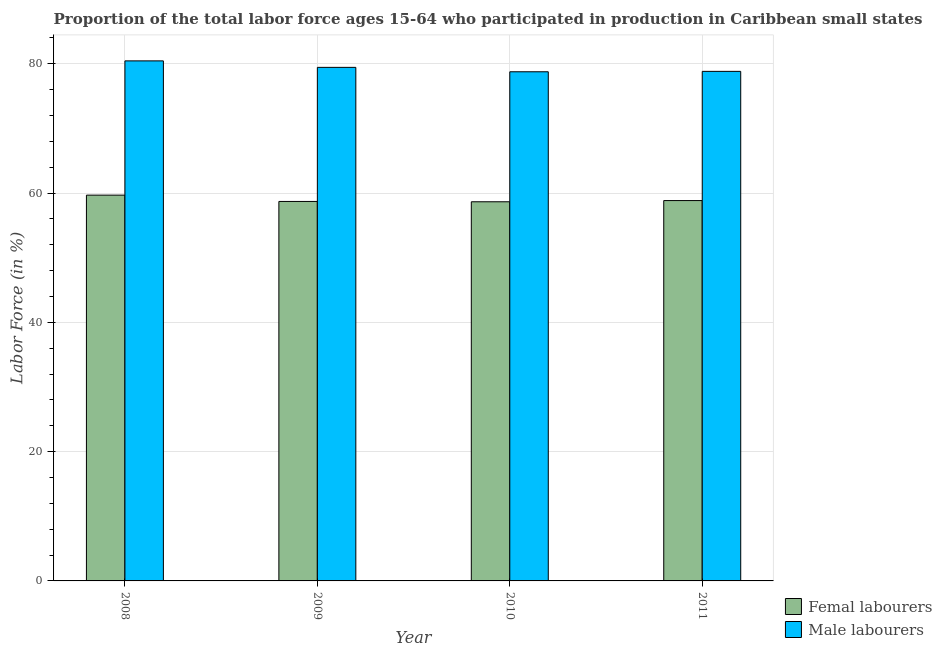How many different coloured bars are there?
Your answer should be very brief. 2. How many groups of bars are there?
Provide a succinct answer. 4. Are the number of bars on each tick of the X-axis equal?
Keep it short and to the point. Yes. How many bars are there on the 3rd tick from the right?
Give a very brief answer. 2. What is the label of the 2nd group of bars from the left?
Keep it short and to the point. 2009. What is the percentage of female labor force in 2008?
Your answer should be very brief. 59.68. Across all years, what is the maximum percentage of female labor force?
Make the answer very short. 59.68. Across all years, what is the minimum percentage of male labour force?
Provide a succinct answer. 78.76. In which year was the percentage of male labour force maximum?
Offer a very short reply. 2008. What is the total percentage of female labor force in the graph?
Give a very brief answer. 235.86. What is the difference between the percentage of female labor force in 2009 and that in 2010?
Provide a succinct answer. 0.05. What is the difference between the percentage of male labour force in 2011 and the percentage of female labor force in 2008?
Your response must be concise. -1.62. What is the average percentage of male labour force per year?
Offer a terse response. 79.37. What is the ratio of the percentage of male labour force in 2008 to that in 2009?
Give a very brief answer. 1.01. Is the percentage of male labour force in 2010 less than that in 2011?
Make the answer very short. Yes. What is the difference between the highest and the second highest percentage of male labour force?
Your response must be concise. 1. What is the difference between the highest and the lowest percentage of male labour force?
Offer a terse response. 1.68. Is the sum of the percentage of male labour force in 2008 and 2010 greater than the maximum percentage of female labor force across all years?
Provide a succinct answer. Yes. What does the 2nd bar from the left in 2009 represents?
Provide a short and direct response. Male labourers. What does the 2nd bar from the right in 2009 represents?
Your answer should be very brief. Femal labourers. How many bars are there?
Keep it short and to the point. 8. How many years are there in the graph?
Your answer should be very brief. 4. What is the difference between two consecutive major ticks on the Y-axis?
Your response must be concise. 20. Are the values on the major ticks of Y-axis written in scientific E-notation?
Offer a very short reply. No. Where does the legend appear in the graph?
Provide a succinct answer. Bottom right. How many legend labels are there?
Your answer should be compact. 2. How are the legend labels stacked?
Keep it short and to the point. Vertical. What is the title of the graph?
Offer a very short reply. Proportion of the total labor force ages 15-64 who participated in production in Caribbean small states. Does "Food and tobacco" appear as one of the legend labels in the graph?
Keep it short and to the point. No. What is the label or title of the X-axis?
Offer a terse response. Year. What is the Labor Force (in %) in Femal labourers in 2008?
Offer a terse response. 59.68. What is the Labor Force (in %) in Male labourers in 2008?
Ensure brevity in your answer.  80.44. What is the Labor Force (in %) of Femal labourers in 2009?
Offer a very short reply. 58.7. What is the Labor Force (in %) in Male labourers in 2009?
Your response must be concise. 79.44. What is the Labor Force (in %) in Femal labourers in 2010?
Keep it short and to the point. 58.65. What is the Labor Force (in %) in Male labourers in 2010?
Your answer should be compact. 78.76. What is the Labor Force (in %) in Femal labourers in 2011?
Your response must be concise. 58.83. What is the Labor Force (in %) in Male labourers in 2011?
Provide a succinct answer. 78.82. Across all years, what is the maximum Labor Force (in %) in Femal labourers?
Give a very brief answer. 59.68. Across all years, what is the maximum Labor Force (in %) in Male labourers?
Your response must be concise. 80.44. Across all years, what is the minimum Labor Force (in %) of Femal labourers?
Make the answer very short. 58.65. Across all years, what is the minimum Labor Force (in %) in Male labourers?
Your response must be concise. 78.76. What is the total Labor Force (in %) of Femal labourers in the graph?
Ensure brevity in your answer.  235.86. What is the total Labor Force (in %) in Male labourers in the graph?
Provide a short and direct response. 317.46. What is the difference between the Labor Force (in %) of Femal labourers in 2008 and that in 2009?
Give a very brief answer. 0.98. What is the difference between the Labor Force (in %) of Femal labourers in 2008 and that in 2010?
Make the answer very short. 1.03. What is the difference between the Labor Force (in %) of Male labourers in 2008 and that in 2010?
Your answer should be compact. 1.68. What is the difference between the Labor Force (in %) in Femal labourers in 2008 and that in 2011?
Offer a terse response. 0.84. What is the difference between the Labor Force (in %) in Male labourers in 2008 and that in 2011?
Your answer should be compact. 1.62. What is the difference between the Labor Force (in %) of Femal labourers in 2009 and that in 2010?
Give a very brief answer. 0.05. What is the difference between the Labor Force (in %) in Male labourers in 2009 and that in 2010?
Make the answer very short. 0.68. What is the difference between the Labor Force (in %) of Femal labourers in 2009 and that in 2011?
Provide a succinct answer. -0.13. What is the difference between the Labor Force (in %) in Male labourers in 2009 and that in 2011?
Ensure brevity in your answer.  0.62. What is the difference between the Labor Force (in %) in Femal labourers in 2010 and that in 2011?
Your answer should be compact. -0.19. What is the difference between the Labor Force (in %) of Male labourers in 2010 and that in 2011?
Provide a short and direct response. -0.06. What is the difference between the Labor Force (in %) in Femal labourers in 2008 and the Labor Force (in %) in Male labourers in 2009?
Your response must be concise. -19.76. What is the difference between the Labor Force (in %) in Femal labourers in 2008 and the Labor Force (in %) in Male labourers in 2010?
Your answer should be compact. -19.08. What is the difference between the Labor Force (in %) of Femal labourers in 2008 and the Labor Force (in %) of Male labourers in 2011?
Provide a short and direct response. -19.14. What is the difference between the Labor Force (in %) of Femal labourers in 2009 and the Labor Force (in %) of Male labourers in 2010?
Make the answer very short. -20.06. What is the difference between the Labor Force (in %) in Femal labourers in 2009 and the Labor Force (in %) in Male labourers in 2011?
Ensure brevity in your answer.  -20.12. What is the difference between the Labor Force (in %) in Femal labourers in 2010 and the Labor Force (in %) in Male labourers in 2011?
Provide a short and direct response. -20.17. What is the average Labor Force (in %) of Femal labourers per year?
Provide a short and direct response. 58.96. What is the average Labor Force (in %) of Male labourers per year?
Give a very brief answer. 79.37. In the year 2008, what is the difference between the Labor Force (in %) in Femal labourers and Labor Force (in %) in Male labourers?
Provide a succinct answer. -20.77. In the year 2009, what is the difference between the Labor Force (in %) of Femal labourers and Labor Force (in %) of Male labourers?
Your answer should be compact. -20.74. In the year 2010, what is the difference between the Labor Force (in %) in Femal labourers and Labor Force (in %) in Male labourers?
Your response must be concise. -20.11. In the year 2011, what is the difference between the Labor Force (in %) in Femal labourers and Labor Force (in %) in Male labourers?
Give a very brief answer. -19.99. What is the ratio of the Labor Force (in %) in Femal labourers in 2008 to that in 2009?
Offer a terse response. 1.02. What is the ratio of the Labor Force (in %) in Male labourers in 2008 to that in 2009?
Your response must be concise. 1.01. What is the ratio of the Labor Force (in %) in Femal labourers in 2008 to that in 2010?
Ensure brevity in your answer.  1.02. What is the ratio of the Labor Force (in %) of Male labourers in 2008 to that in 2010?
Your answer should be very brief. 1.02. What is the ratio of the Labor Force (in %) in Femal labourers in 2008 to that in 2011?
Give a very brief answer. 1.01. What is the ratio of the Labor Force (in %) of Male labourers in 2008 to that in 2011?
Make the answer very short. 1.02. What is the ratio of the Labor Force (in %) in Male labourers in 2009 to that in 2010?
Ensure brevity in your answer.  1.01. What is the ratio of the Labor Force (in %) of Male labourers in 2009 to that in 2011?
Make the answer very short. 1.01. What is the ratio of the Labor Force (in %) of Femal labourers in 2010 to that in 2011?
Your response must be concise. 1. What is the difference between the highest and the second highest Labor Force (in %) of Femal labourers?
Provide a succinct answer. 0.84. What is the difference between the highest and the second highest Labor Force (in %) in Male labourers?
Offer a very short reply. 1. What is the difference between the highest and the lowest Labor Force (in %) in Femal labourers?
Provide a succinct answer. 1.03. What is the difference between the highest and the lowest Labor Force (in %) in Male labourers?
Provide a succinct answer. 1.68. 